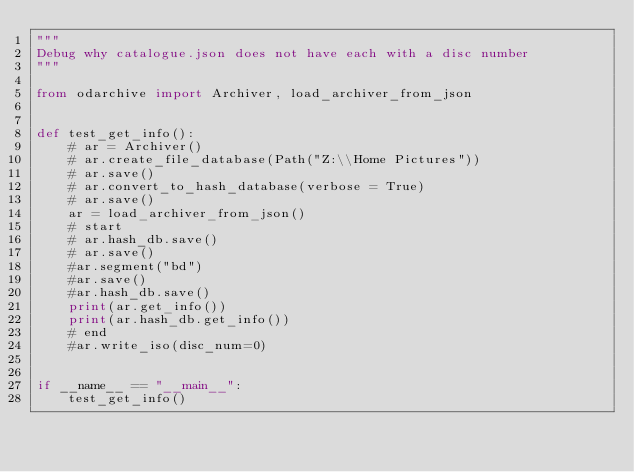<code> <loc_0><loc_0><loc_500><loc_500><_Python_>"""
Debug why catalogue.json does not have each with a disc number
"""

from odarchive import Archiver, load_archiver_from_json


def test_get_info():
    # ar = Archiver()
    # ar.create_file_database(Path("Z:\\Home Pictures"))
    # ar.save()
    # ar.convert_to_hash_database(verbose = True)
    # ar.save()
    ar = load_archiver_from_json()
    # start
    # ar.hash_db.save()
    # ar.save()
    #ar.segment("bd")
    #ar.save()
    #ar.hash_db.save()
    print(ar.get_info())
    print(ar.hash_db.get_info())
    # end
    #ar.write_iso(disc_num=0)


if __name__ == "__main__":
    test_get_info()
</code> 